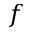Convert formula to latex. <formula><loc_0><loc_0><loc_500><loc_500>f</formula> 